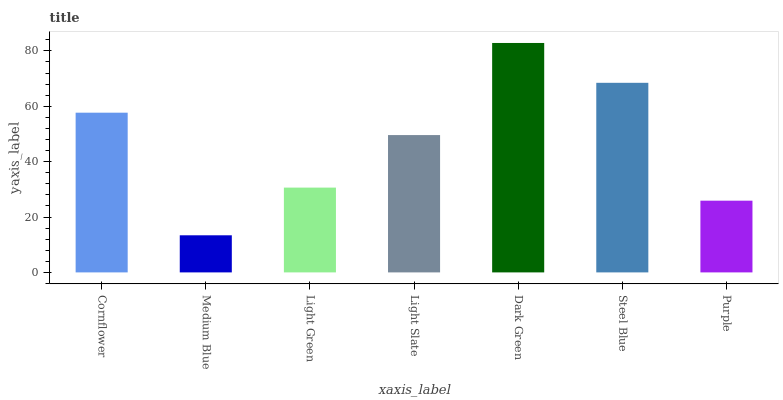Is Light Green the minimum?
Answer yes or no. No. Is Light Green the maximum?
Answer yes or no. No. Is Light Green greater than Medium Blue?
Answer yes or no. Yes. Is Medium Blue less than Light Green?
Answer yes or no. Yes. Is Medium Blue greater than Light Green?
Answer yes or no. No. Is Light Green less than Medium Blue?
Answer yes or no. No. Is Light Slate the high median?
Answer yes or no. Yes. Is Light Slate the low median?
Answer yes or no. Yes. Is Dark Green the high median?
Answer yes or no. No. Is Medium Blue the low median?
Answer yes or no. No. 